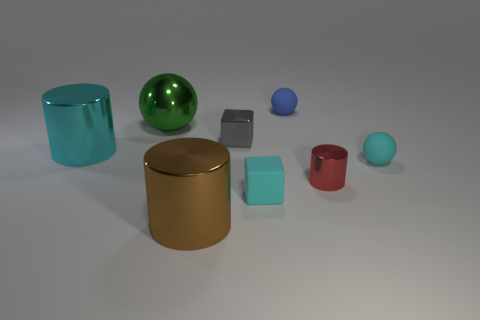What number of cylinders are green rubber objects or green things?
Your answer should be very brief. 0. Is the number of cyan things right of the red metallic cylinder the same as the number of metallic cylinders right of the large brown shiny thing?
Your answer should be very brief. Yes. What color is the big metal ball?
Offer a very short reply. Green. How many things are either small rubber objects in front of the tiny red cylinder or red cylinders?
Give a very brief answer. 2. There is a matte sphere right of the small red thing; does it have the same size as the cyan thing that is in front of the small cyan matte ball?
Your response must be concise. Yes. How many things are either objects that are right of the small red metal cylinder or tiny rubber objects that are behind the small cylinder?
Make the answer very short. 2. Is the material of the cyan cylinder the same as the big green ball left of the gray thing?
Offer a very short reply. Yes. What shape is the metallic thing that is left of the gray metal thing and right of the big green thing?
Ensure brevity in your answer.  Cylinder. How many other objects are there of the same color as the big sphere?
Your response must be concise. 0. What is the shape of the large green object?
Ensure brevity in your answer.  Sphere. 